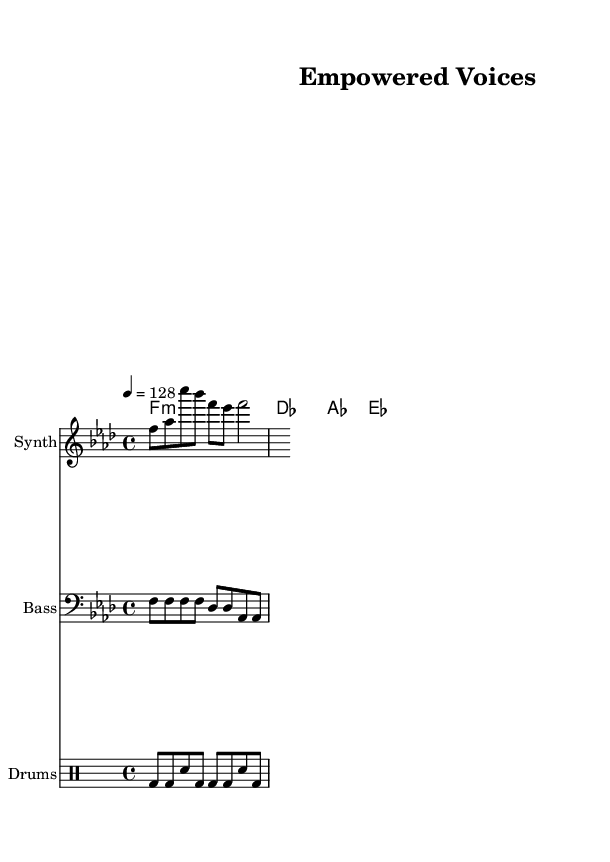What is the key of the piece? The key signature is F minor, indicated by the presence of four flats (B, E, A, and D) which are typically shown at the beginning of the staff.
Answer: F minor What is the time signature of this music? The time signature is 4/4, which is noted at the beginning of the piece. This means there are four beats in each measure and a quarter note receives one beat.
Answer: 4/4 What is the tempo marking for this piece? The tempo marking indicates the speed of the piece is set at 128 beats per minute, shown on the sheet as "4 = 128".
Answer: 128 What instrument plays the melody in this composition? The melody is written for a synth, as indicated by the staff label "Synth" placed alongside the melody notes.
Answer: Synth How many measures are present in the melody? By counting the groups of notes, we find that there are a total of 8 measures in the melody part since each measure contains a quarter note sequence aligning with the 4/4 time signature.
Answer: 8 What chord is played in the first measure of the harmonies? The chord played in the first measure is F minor, which is represented by "f1:m" in the chord mode section, indicating an F minor chord.
Answer: F minor What is the rhythmic pattern of the bass line? The bass line features a rhythm of alternating quarter and eighth notes, consistent with the four beats per measure in 4/4 time, but we can summarize that it follows a repeating pattern of quarter notes throughout the first few measures.
Answer: Alternating patterns 